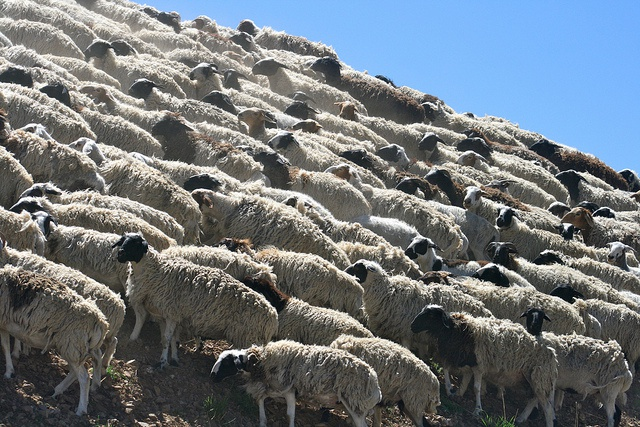Describe the objects in this image and their specific colors. I can see sheep in lightgray, gray, black, and darkgray tones, sheep in lightgray, gray, and black tones, sheep in lightgray, gray, black, and ivory tones, sheep in lightgray, black, gray, and ivory tones, and sheep in lightgray, gray, and black tones in this image. 